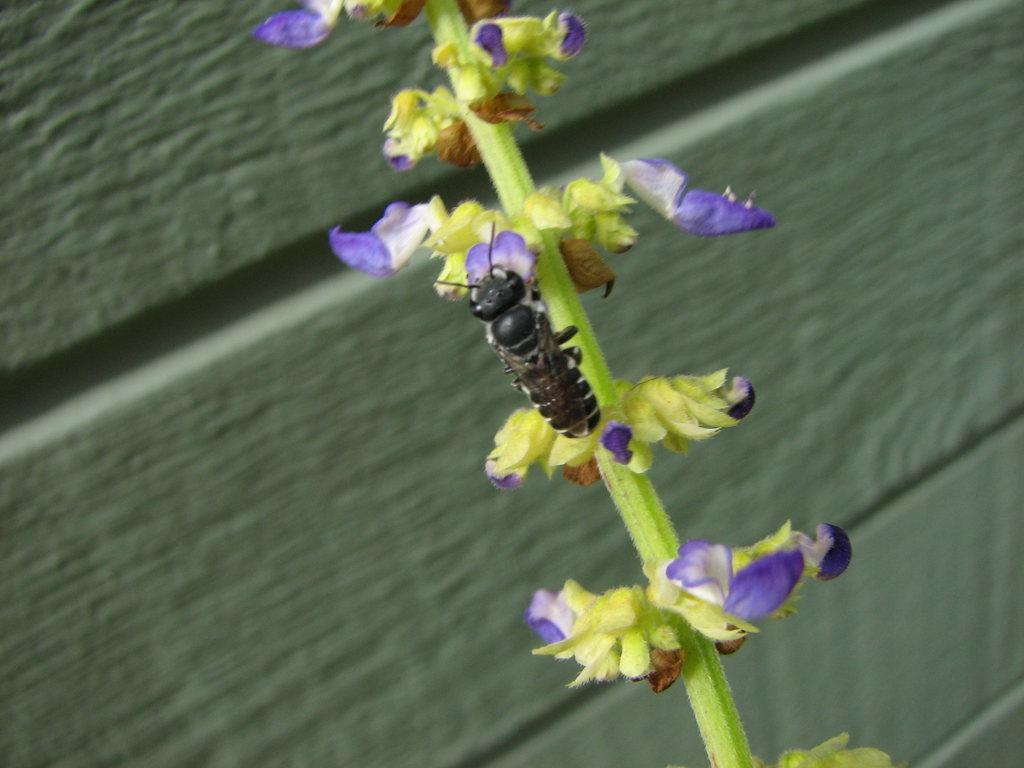What type of living organism can be seen in the image? There is a plant in the image. What specific feature of the plant is mentioned? The plant has flowers. Are there any other living organisms interacting with the plant? Yes, there is a bee on the plant. What can be seen in the background of the image? There is a wall visible behind the plant. What is the mass of the toad sitting on the plant in the image? There is no toad present in the image; it features a plant with flowers and a bee. How many oranges are visible on the plant in the image? There are no oranges present in the image; the plant has flowers and a bee. 